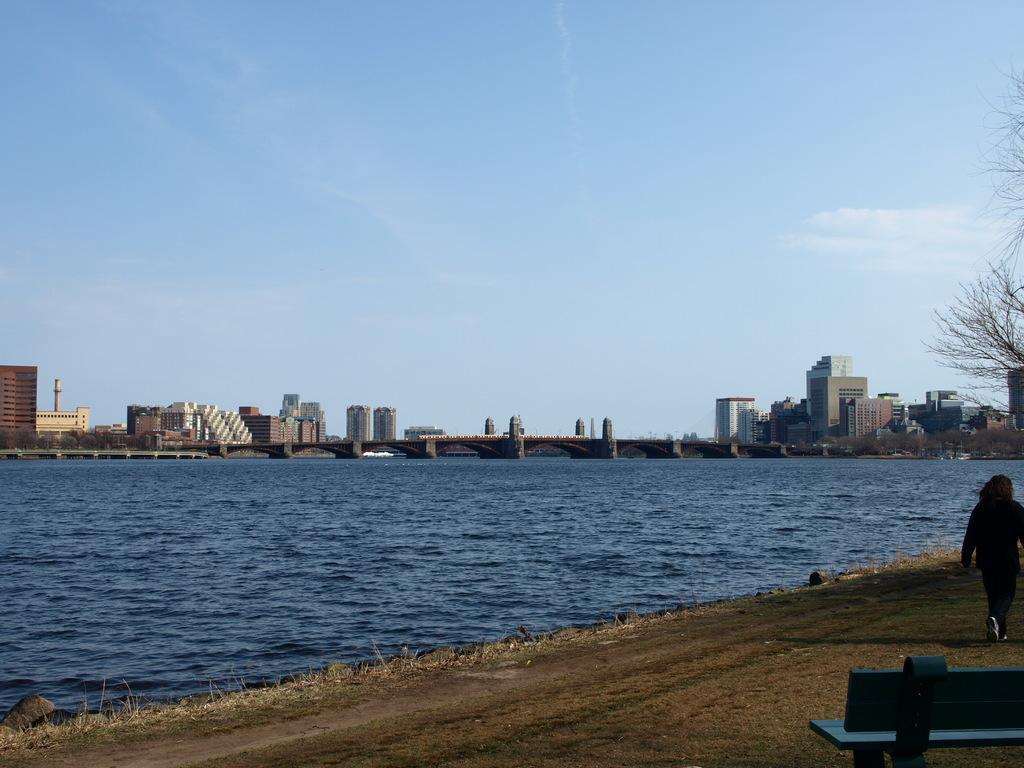In one or two sentences, can you explain what this image depicts? In this image I can see a person walking, I can also see a bench in blue color. Background I can see water in blue color, few buildings in white and cream color and the sky is in white and blue color. 